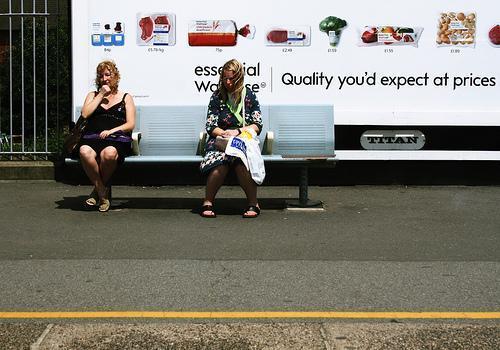How many people are there?
Give a very brief answer. 2. 